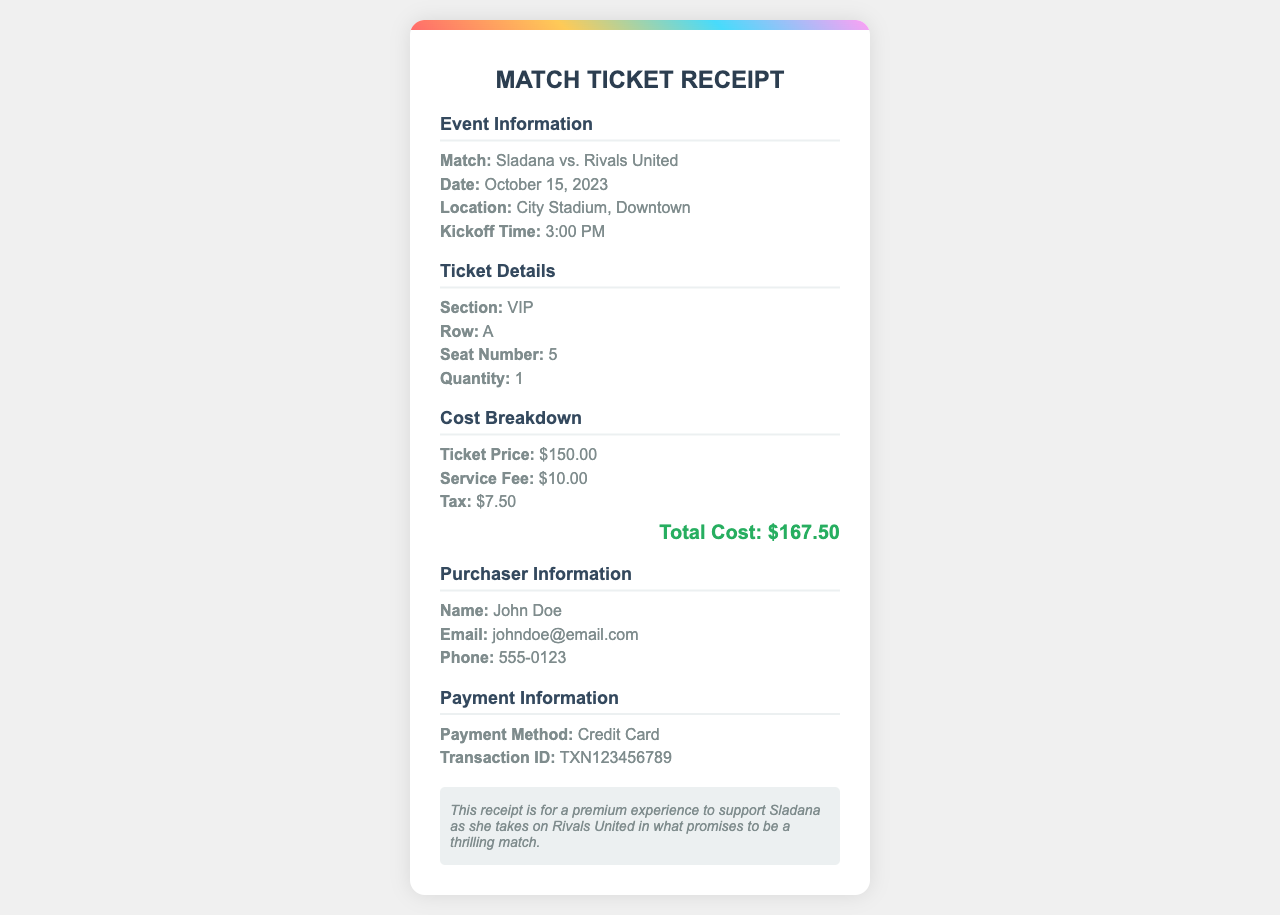What is the match date? The match date is specified in the event information section of the document.
Answer: October 15, 2023 What is the seating section? The seating section is mentioned in the ticket details section of the document.
Answer: VIP How much is the ticket price? The ticket price is provided in the cost breakdown section of the document.
Answer: $150.00 What is the quantity of tickets purchased? The quantity of tickets is stated in the ticket details section of the document.
Answer: 1 What is the total cost? The total cost is the final figure presented in the cost breakdown section of the document.
Answer: $167.50 Who is the purchaser? The purchaser's name is given in the purchaser information section of the document.
Answer: John Doe What is the transaction ID? The transaction ID is mentioned in the payment information section of the document.
Answer: TXN123456789 What was the kickoff time? The kickoff time is listed in the event information section of the document.
Answer: 3:00 PM What method of payment was used? The method of payment is indicated in the payment information section of the document.
Answer: Credit Card 